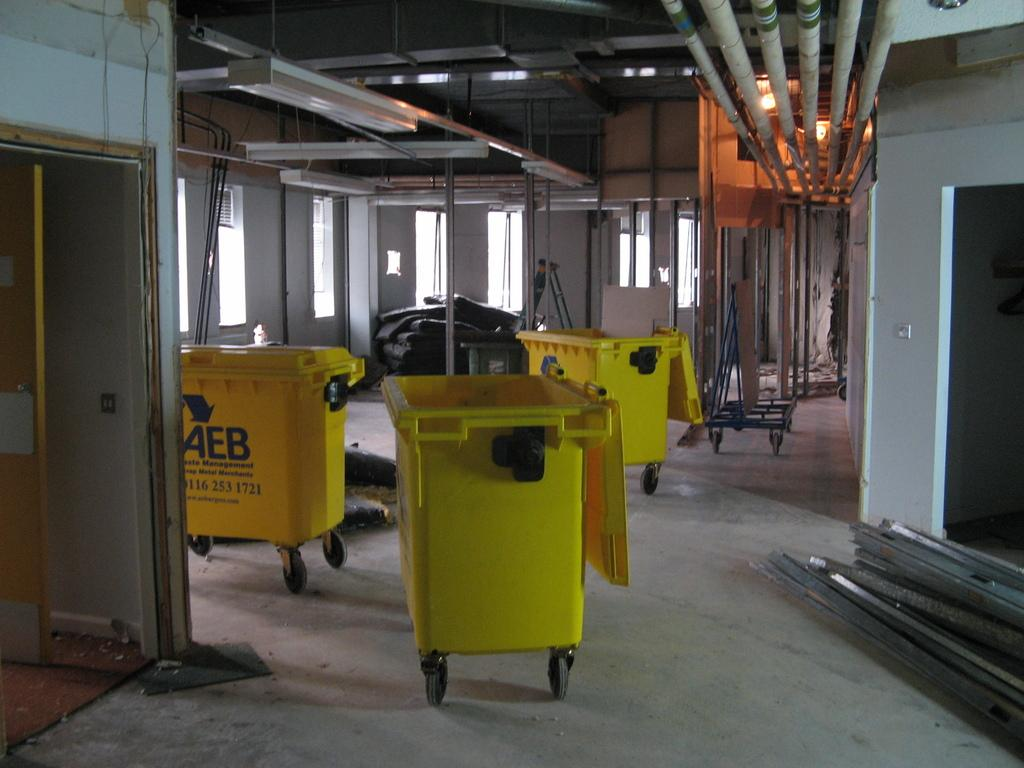<image>
Relay a brief, clear account of the picture shown. A group of three AEB waste management bright yellow bins on wheels in a construction building. 